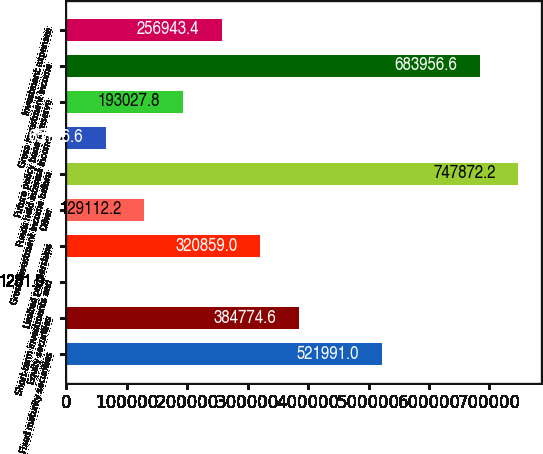Convert chart. <chart><loc_0><loc_0><loc_500><loc_500><bar_chart><fcel>Fixed maturity securities<fcel>Equity securities<fcel>Short-term investments and<fcel>Limited partnerships<fcel>Other<fcel>Gross investment income before<fcel>Funds held interest income<fcel>Future policy benefit reserve<fcel>Gross investment income<fcel>Investment expenses<nl><fcel>521991<fcel>384775<fcel>1281<fcel>320859<fcel>129112<fcel>747872<fcel>65196.6<fcel>193028<fcel>683957<fcel>256943<nl></chart> 